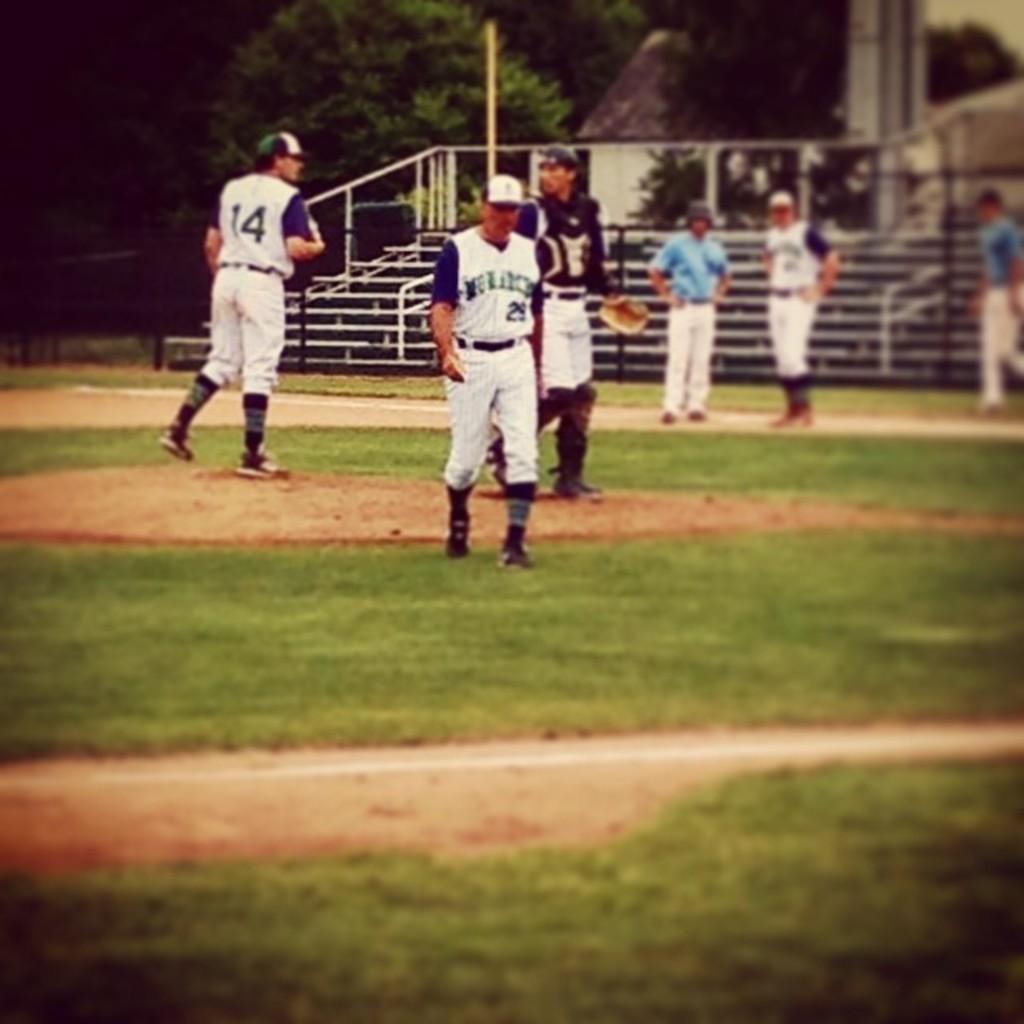How would you summarize this image in a sentence or two? In the image there are few players on the ground and behind them there are stairs and in the background there are trees. 